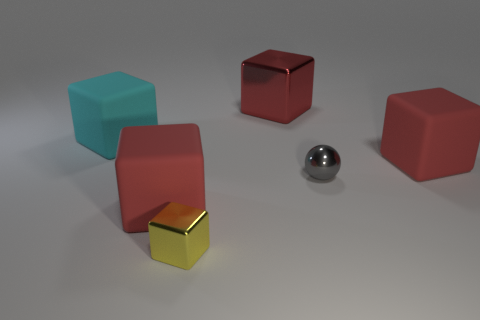Can you infer the light source in this image? Based on the shadows and the highlights on the objects, the light source seems to be coming from the upper left side of the image. It creates soft-edged shadows on the ground, indicating that the light source is not extremely close to the objects.  Do the shadows provide any information about the positioning of the objects relative to each other? Yes, the shadows suggest that the objects are arranged at varying distances from each other. For example, the longer shadow of the red cube on the left points towards the gray sphere, indicating that the sphere is further away from the light source compared to that cube. 